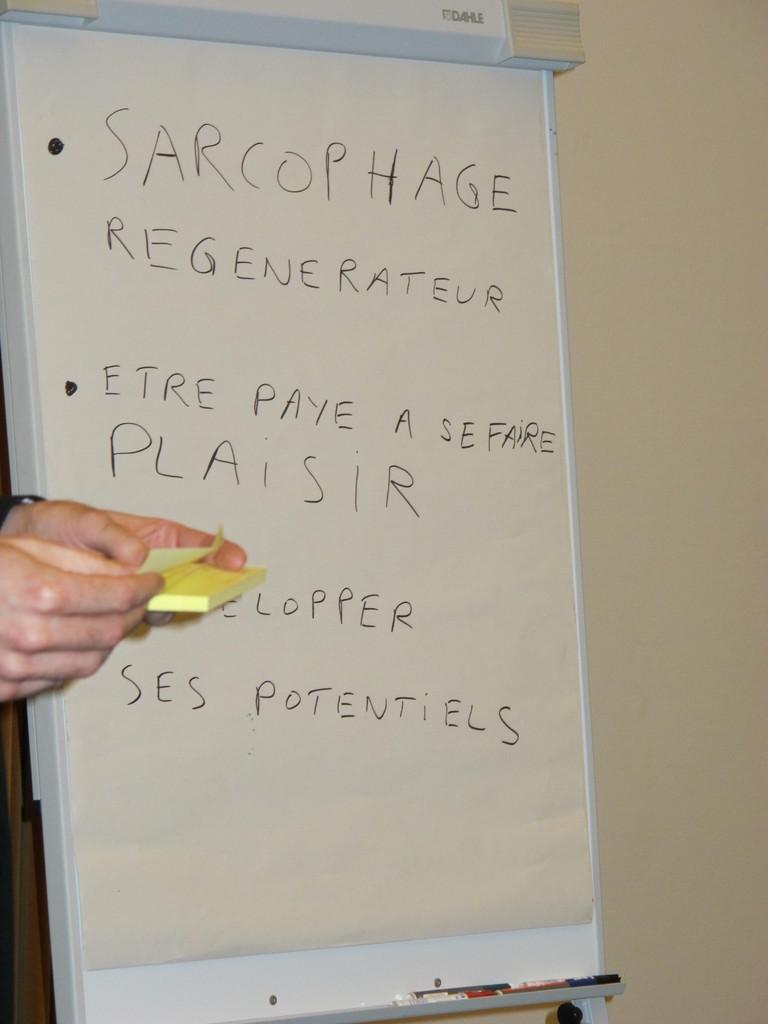Provide a one-sentence caption for the provided image. An easel pad has Sarcophage written in large letters at the top. 